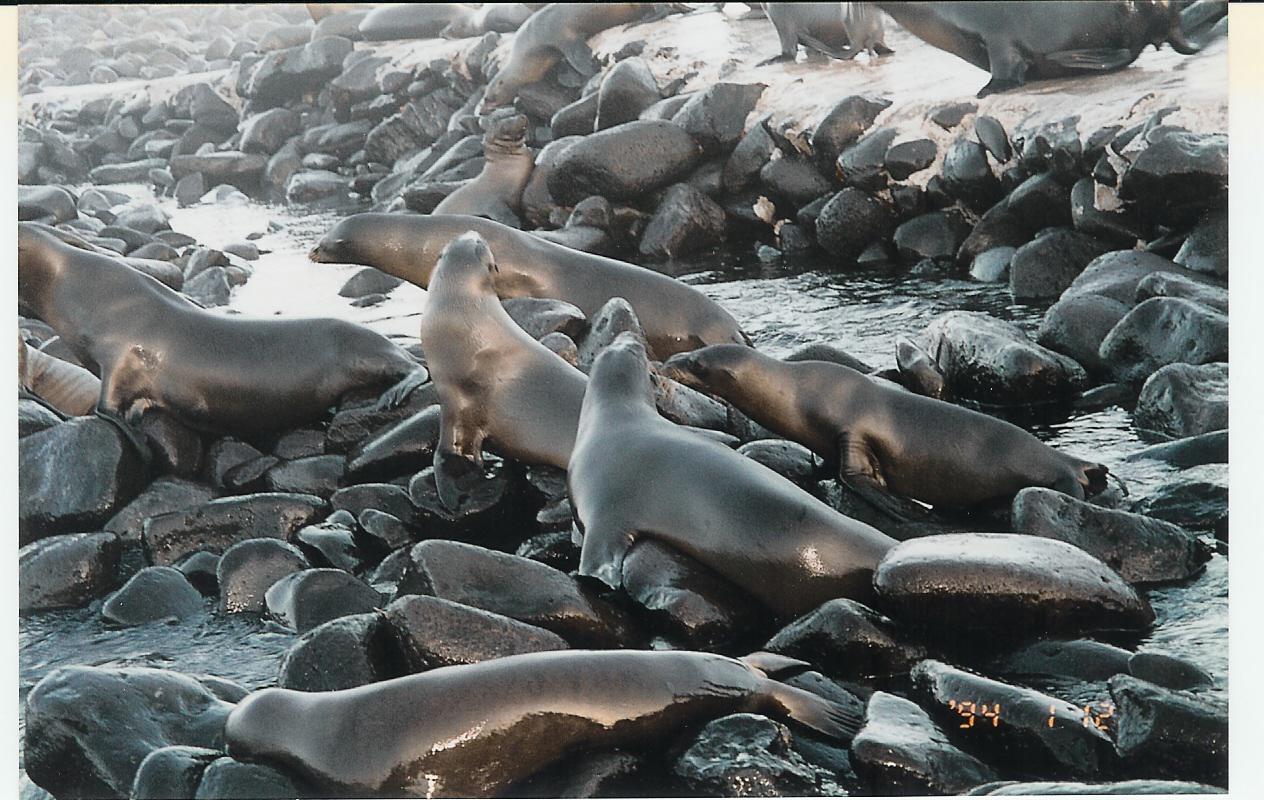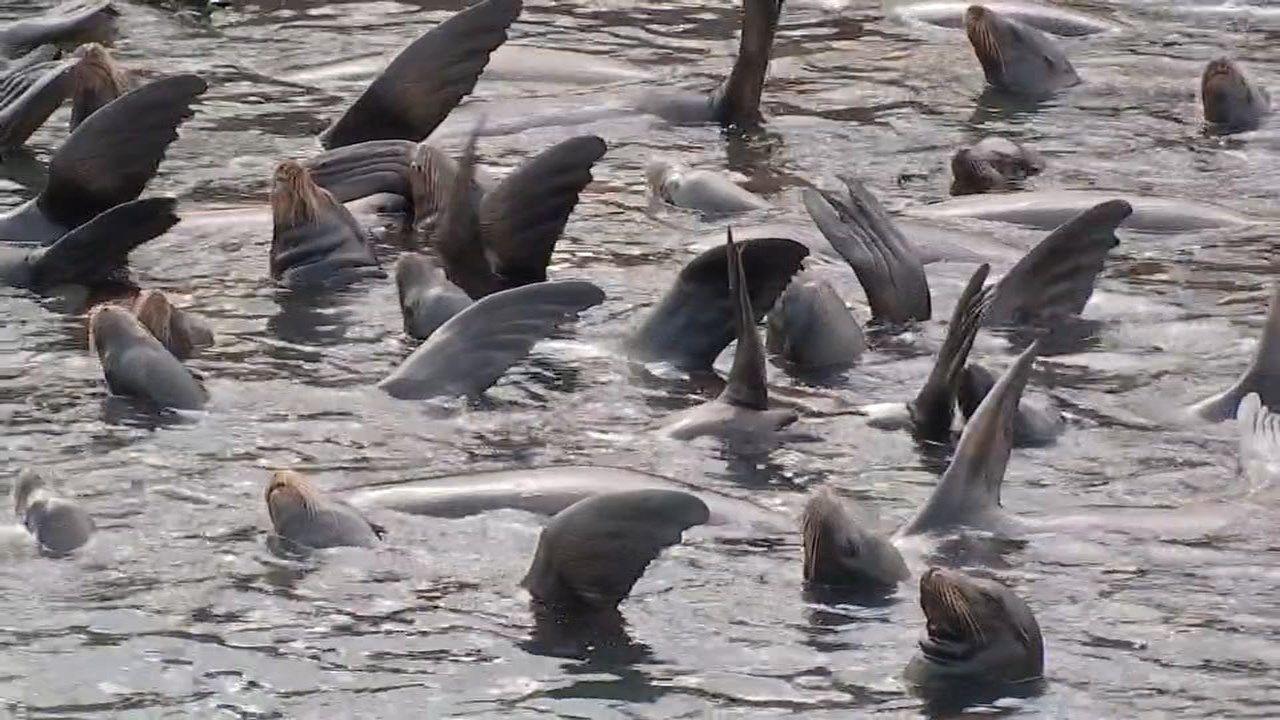The first image is the image on the left, the second image is the image on the right. Considering the images on both sides, is "There are at least 5 brown seal in a group with there head head high in at least four directions." valid? Answer yes or no. No. The first image is the image on the left, the second image is the image on the right. Examine the images to the left and right. Is the description "Seals are in various poses atop large rocks that extend out into the water, with water on both sides, in one image." accurate? Answer yes or no. No. 